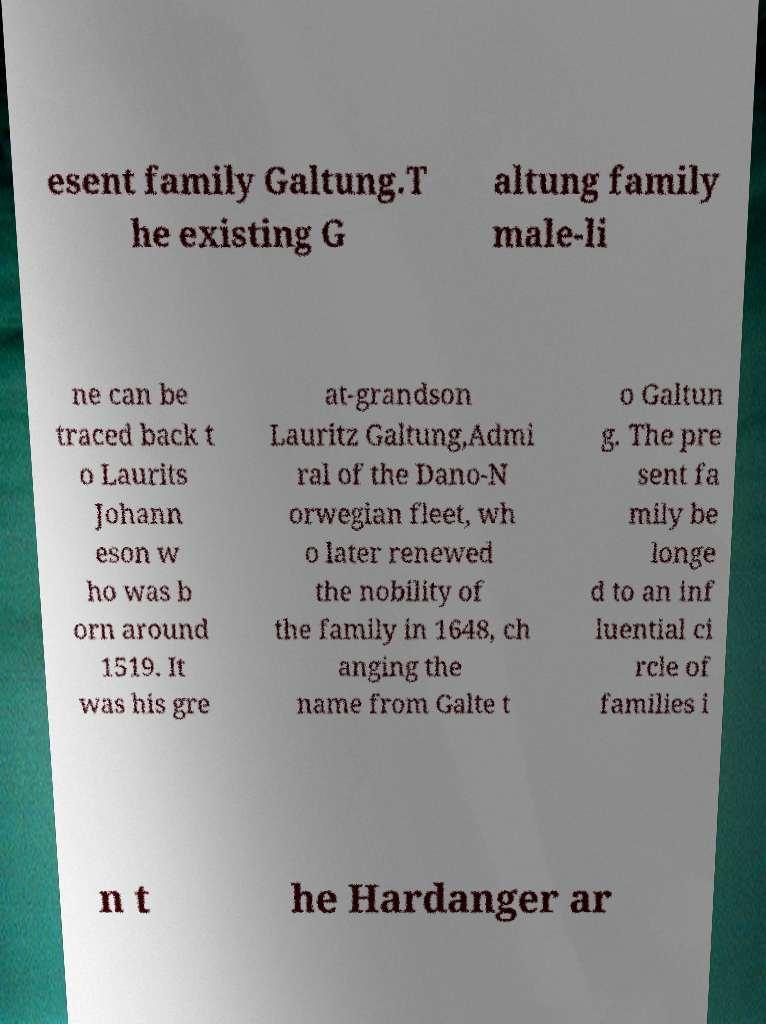Could you extract and type out the text from this image? esent family Galtung.T he existing G altung family male-li ne can be traced back t o Laurits Johann eson w ho was b orn around 1519. It was his gre at-grandson Lauritz Galtung,Admi ral of the Dano-N orwegian fleet, wh o later renewed the nobility of the family in 1648, ch anging the name from Galte t o Galtun g. The pre sent fa mily be longe d to an inf luential ci rcle of families i n t he Hardanger ar 